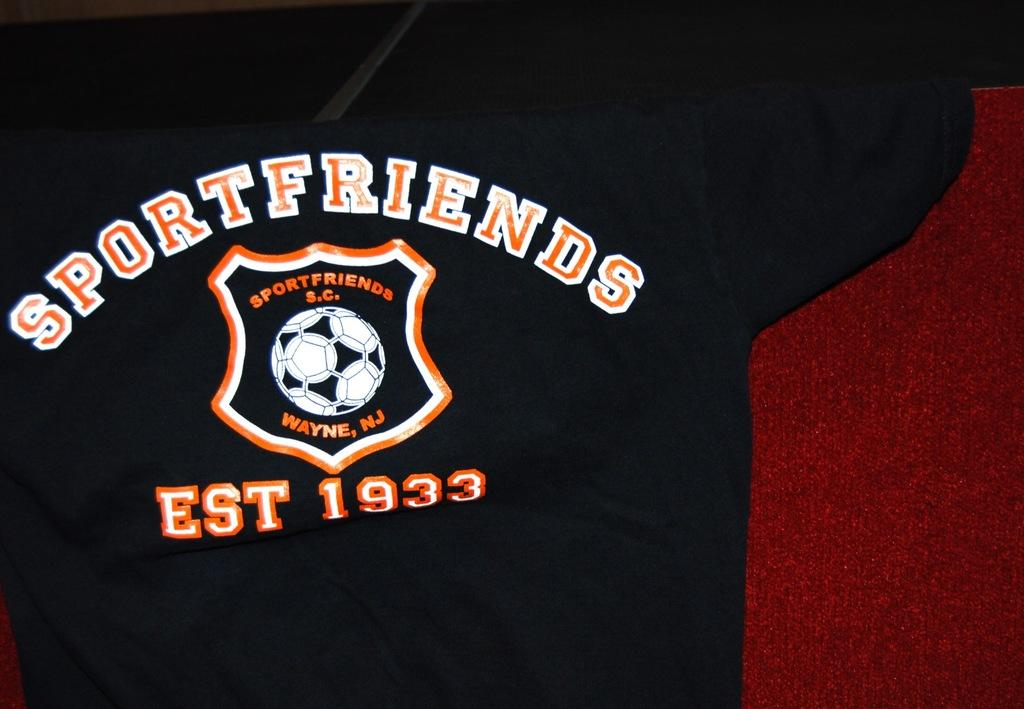<image>
Create a compact narrative representing the image presented. A black shirt with orange and white lettering sayings sportfriends 